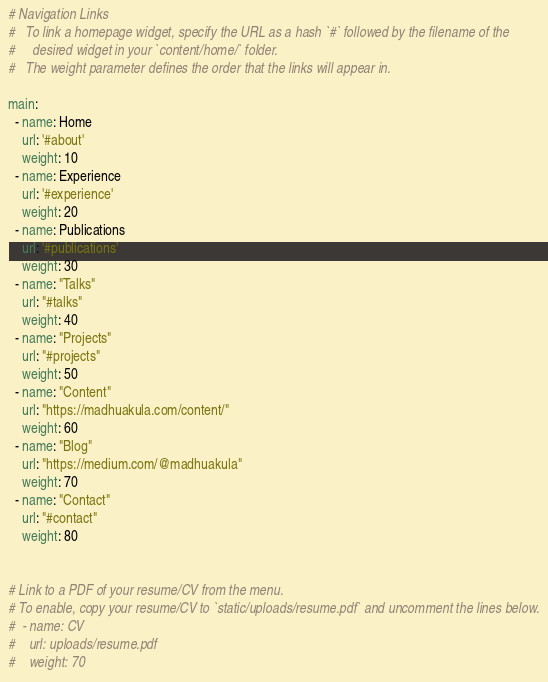<code> <loc_0><loc_0><loc_500><loc_500><_YAML_># Navigation Links
#   To link a homepage widget, specify the URL as a hash `#` followed by the filename of the
#     desired widget in your `content/home/` folder.
#   The weight parameter defines the order that the links will appear in.

main:
  - name: Home
    url: '#about'
    weight: 10
  - name: Experience
    url: '#experience'
    weight: 20
  - name: Publications
    url: '#publications'
    weight: 30
  - name: "Talks"
    url: "#talks"
    weight: 40
  - name: "Projects"
    url: "#projects"
    weight: 50
  - name: "Content"
    url: "https://madhuakula.com/content/"
    weight: 60
  - name: "Blog"
    url: "https://medium.com/@madhuakula"
    weight: 70
  - name: "Contact"
    url: "#contact"
    weight: 80


# Link to a PDF of your resume/CV from the menu.
# To enable, copy your resume/CV to `static/uploads/resume.pdf` and uncomment the lines below.
#  - name: CV
#    url: uploads/resume.pdf
#    weight: 70
</code> 